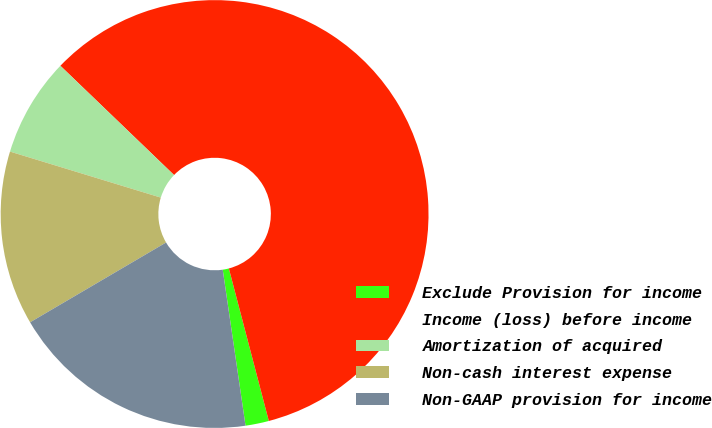Convert chart to OTSL. <chart><loc_0><loc_0><loc_500><loc_500><pie_chart><fcel>Exclude Provision for income<fcel>Income (loss) before income<fcel>Amortization of acquired<fcel>Non-cash interest expense<fcel>Non-GAAP provision for income<nl><fcel>1.77%<fcel>58.73%<fcel>7.47%<fcel>13.16%<fcel>18.86%<nl></chart> 